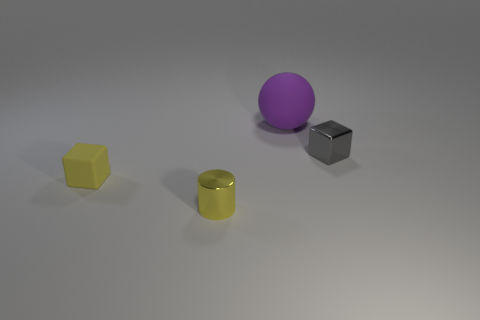What is the shape of the tiny object that is left of the metal cylinder?
Provide a succinct answer. Cube. There is another yellow object that is made of the same material as the large object; what shape is it?
Provide a short and direct response. Cube. How many metal objects are either yellow objects or big balls?
Make the answer very short. 1. There is a yellow object that is in front of the block on the left side of the gray cube; what number of yellow things are in front of it?
Provide a short and direct response. 0. Does the object that is in front of the tiny yellow rubber object have the same size as the rubber object that is on the left side of the big purple matte object?
Offer a terse response. Yes. There is another object that is the same shape as the small gray object; what material is it?
Provide a succinct answer. Rubber. How many tiny things are either yellow cylinders or purple balls?
Offer a terse response. 1. What material is the yellow cube?
Give a very brief answer. Rubber. There is a small thing that is behind the yellow shiny thing and on the right side of the yellow matte object; what material is it made of?
Provide a succinct answer. Metal. There is a small metallic cube; is its color the same as the matte object that is in front of the purple ball?
Your response must be concise. No. 